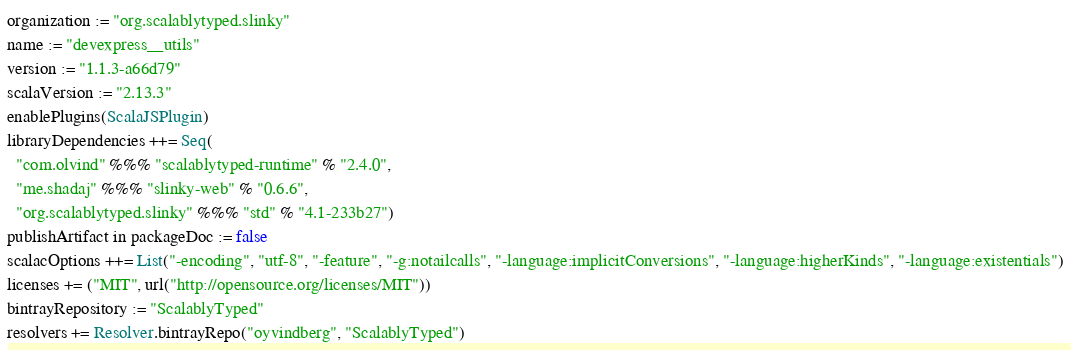<code> <loc_0><loc_0><loc_500><loc_500><_Scala_>organization := "org.scalablytyped.slinky"
name := "devexpress__utils"
version := "1.1.3-a66d79"
scalaVersion := "2.13.3"
enablePlugins(ScalaJSPlugin)
libraryDependencies ++= Seq(
  "com.olvind" %%% "scalablytyped-runtime" % "2.4.0",
  "me.shadaj" %%% "slinky-web" % "0.6.6",
  "org.scalablytyped.slinky" %%% "std" % "4.1-233b27")
publishArtifact in packageDoc := false
scalacOptions ++= List("-encoding", "utf-8", "-feature", "-g:notailcalls", "-language:implicitConversions", "-language:higherKinds", "-language:existentials")
licenses += ("MIT", url("http://opensource.org/licenses/MIT"))
bintrayRepository := "ScalablyTyped"
resolvers += Resolver.bintrayRepo("oyvindberg", "ScalablyTyped")
</code> 